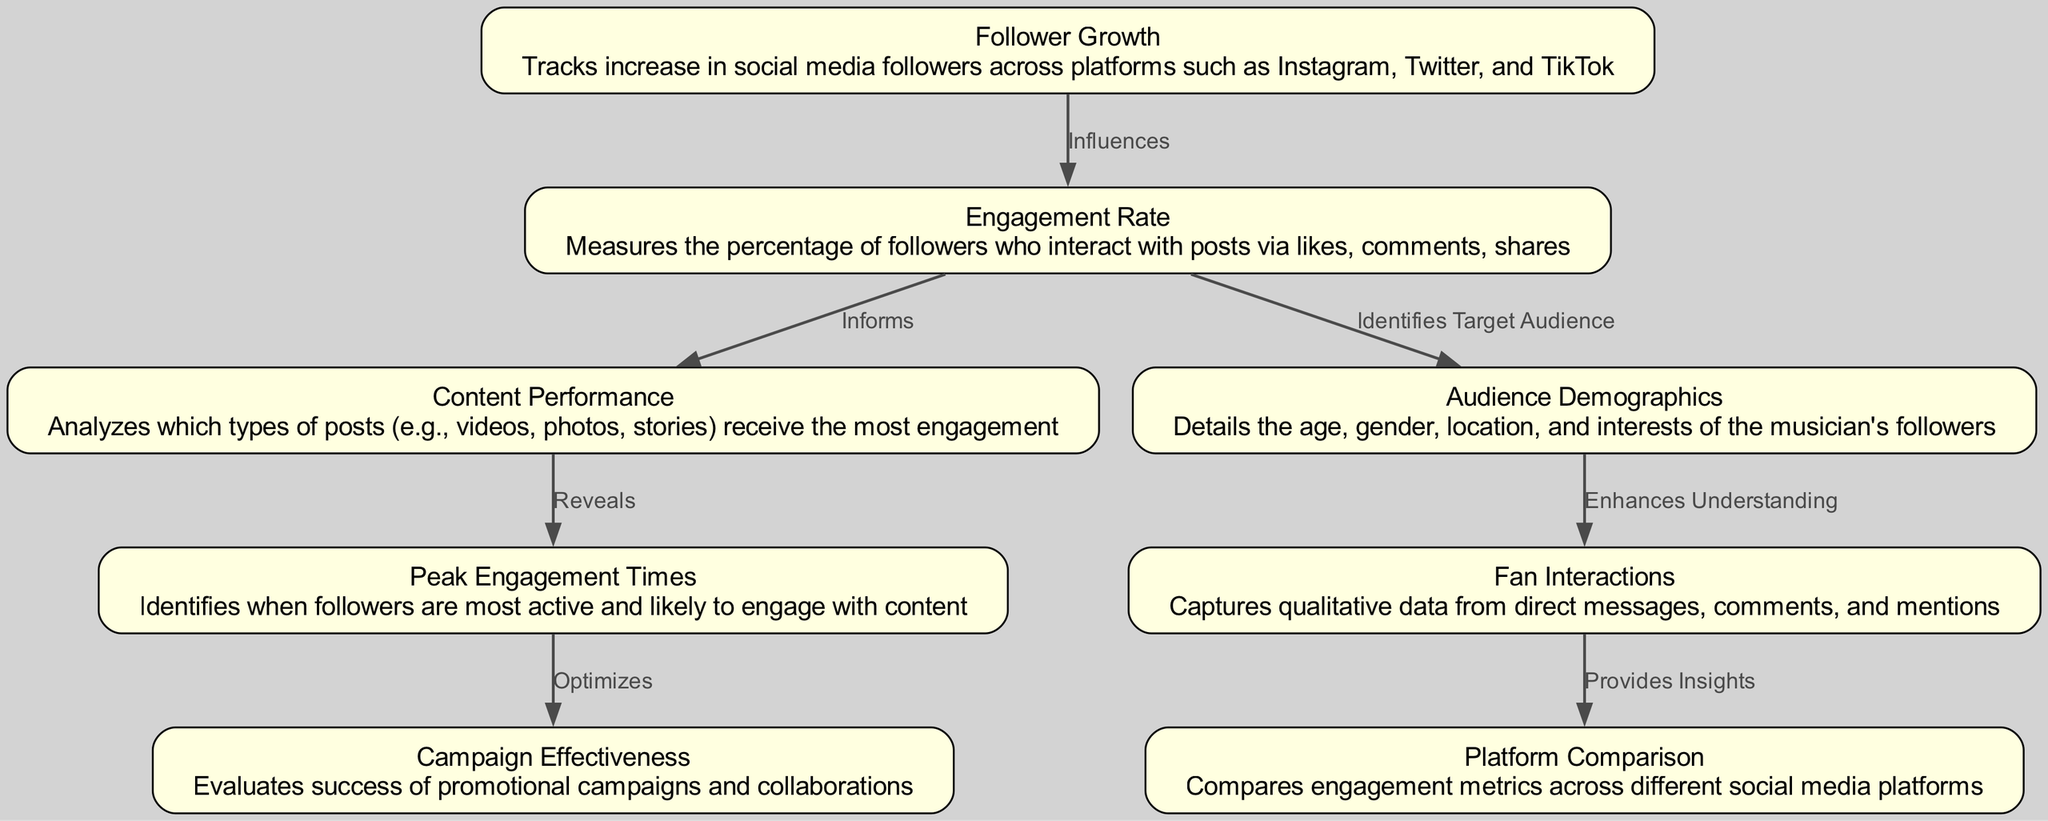What is the total number of nodes in the diagram? The diagram includes eight distinct nodes that represent different social media engagement metrics for musicians.
Answer: 8 What does the "Engagement Rate" influence? According to the diagram, the "Engagement Rate" influences the "Follower Growth," meaning it impacts the increase in followers on social media platforms.
Answer: Follower Growth Which node analyzes post types for engagement? The "Content Performance" node is specifically focused on analyzing which types of posts, such as videos and photos, receive the most engagement from followers.
Answer: Content Performance What is identified by the "Engagement Rate"? The "Engagement Rate" identifies the target audience by measuring the percentage of followers who interact with posts through likes, comments, and shares.
Answer: Target Audience How does "Peak Engagement Times" affect "Campaign Effectiveness"? The "Peak Engagement Times" node enhances the "Campaign Effectiveness" by identifying when followers are most active, thereby optimizing promotional campaigns for better results.
Answer: Optimizes What type of data is captured by the "Fan Interactions" node? The "Fan Interactions" node captures qualitative data that includes direct messages, comments, and mentions from followers on social media.
Answer: Qualitative data What is the relationship between "Follower Growth" and "Engagement Rate"? "Follower Growth" is influenced by the "Engagement Rate," indicating that as engagement increases, so does the growth in followers.
Answer: Influences What aspect of social media does "Platform Comparison" provide insights into? The "Platform Comparison" node provides insights into the engagement metrics, allowing musicians to compare performance across different social media platforms.
Answer: Engagement metrics 